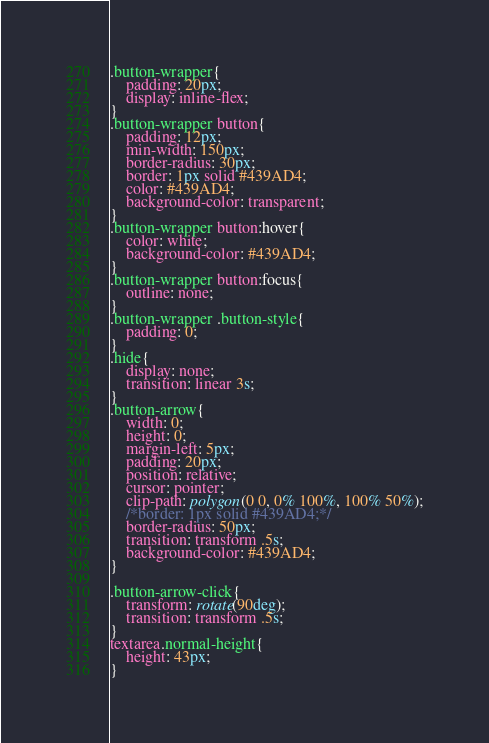Convert code to text. <code><loc_0><loc_0><loc_500><loc_500><_CSS_>.button-wrapper{
    padding: 20px;
    display: inline-flex;
}
.button-wrapper button{
    padding: 12px;
    min-width: 150px;
    border-radius: 30px;
    border: 1px solid #439AD4;
    color: #439AD4;
    background-color: transparent;
}
.button-wrapper button:hover{
    color: white;
    background-color: #439AD4;
}
.button-wrapper button:focus{
    outline: none;
}
.button-wrapper .button-style{
    padding: 0;
}
.hide{
    display: none;
    transition: linear 3s;
}
.button-arrow{
    width: 0;
    height: 0;
    margin-left: 5px;
    padding: 20px;
    position: relative;
    cursor: pointer;
    clip-path: polygon(0 0, 0% 100%, 100% 50%);
    /*border: 1px solid #439AD4;*/
    border-radius: 50px;
    transition: transform .5s;
    background-color: #439AD4;
}

.button-arrow-click{
    transform: rotate(90deg);
    transition: transform .5s;
}
textarea.normal-height{
    height: 43px;
}
</code> 